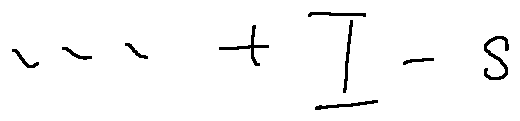Convert formula to latex. <formula><loc_0><loc_0><loc_500><loc_500>\cdots + I - s</formula> 